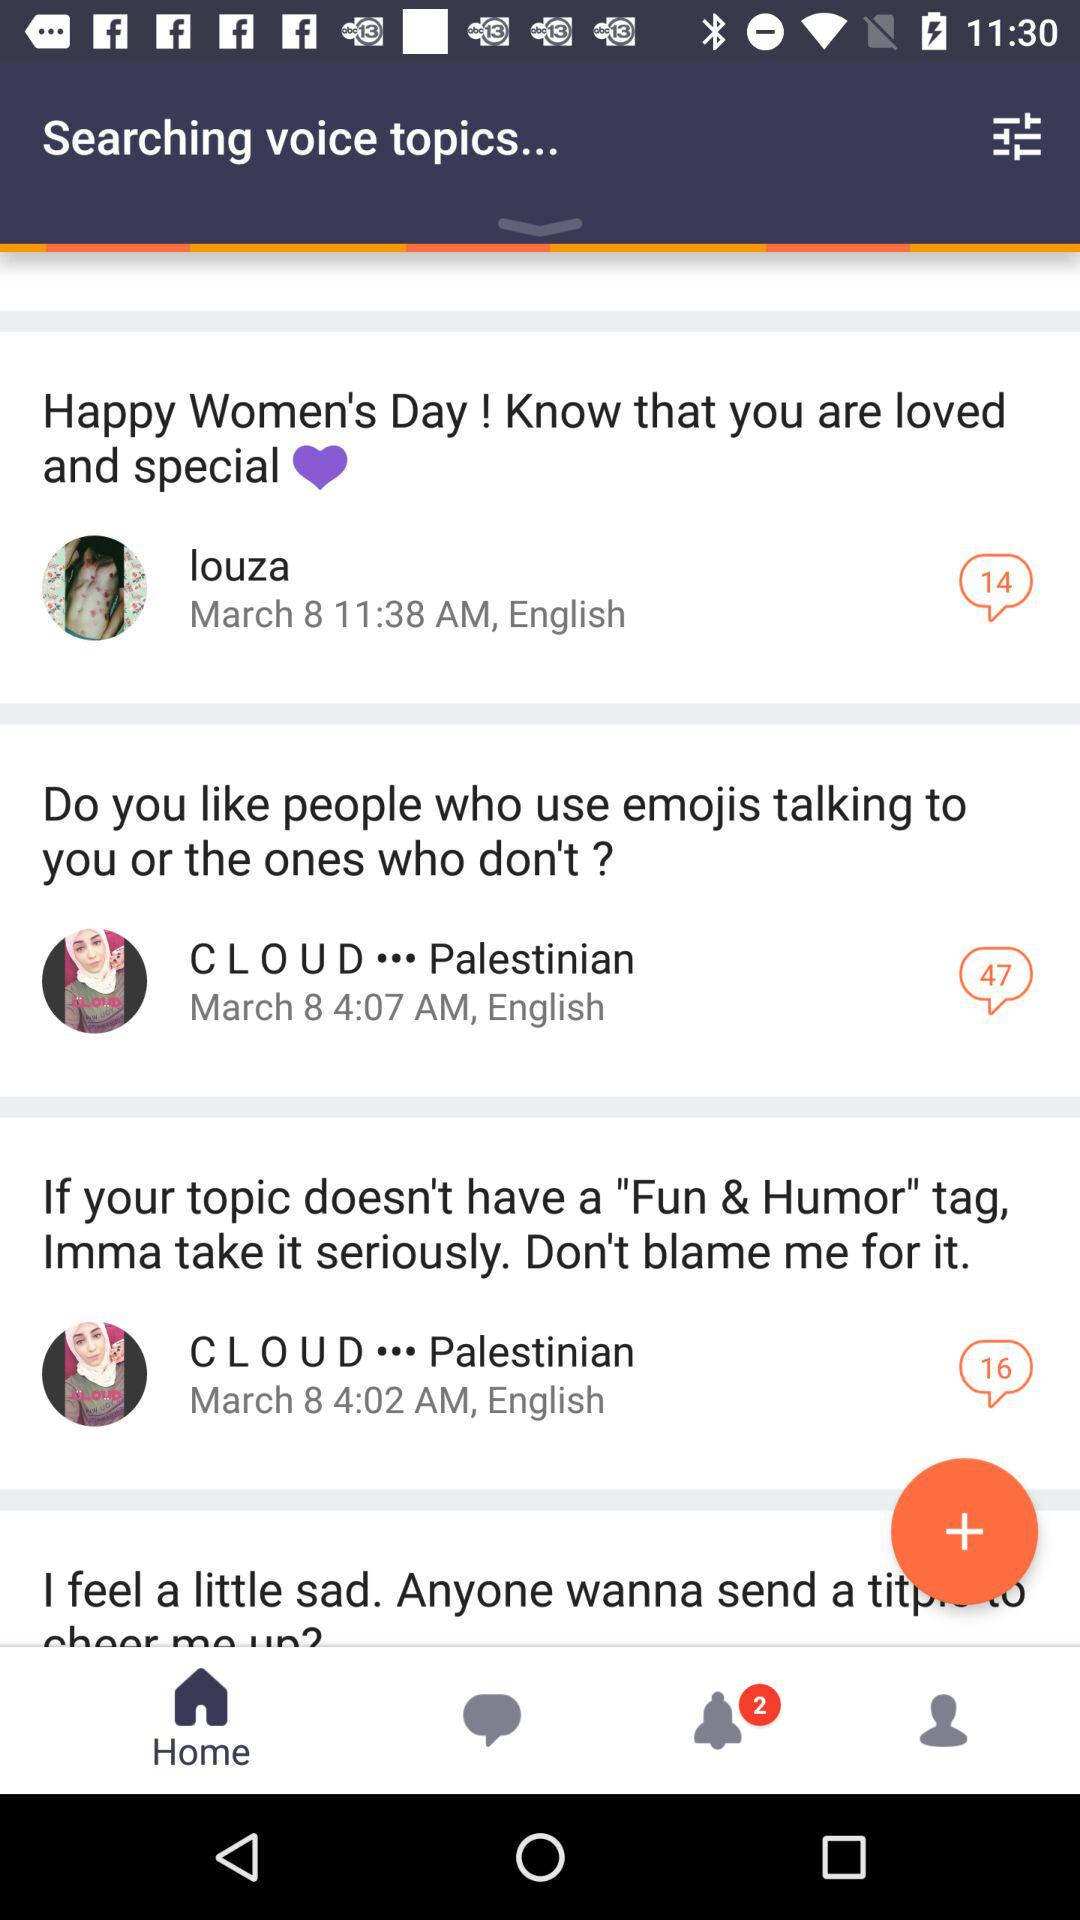How many comments are there on the post by Louza? There are 14 comments on the post by Louza. 